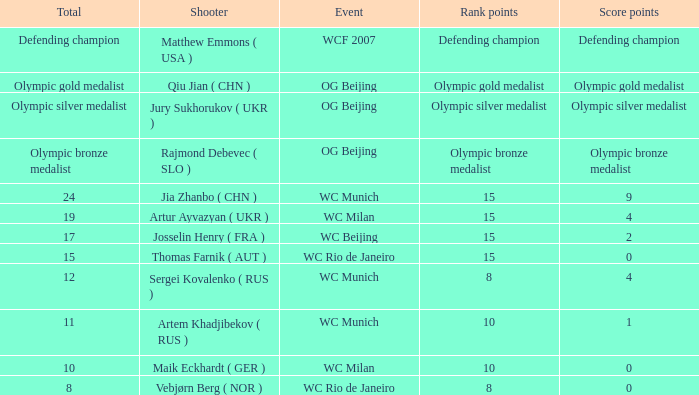With a total of 11, and 10 rank points, what are the score points? 1.0. Could you parse the entire table? {'header': ['Total', 'Shooter', 'Event', 'Rank points', 'Score points'], 'rows': [['Defending champion', 'Matthew Emmons ( USA )', 'WCF 2007', 'Defending champion', 'Defending champion'], ['Olympic gold medalist', 'Qiu Jian ( CHN )', 'OG Beijing', 'Olympic gold medalist', 'Olympic gold medalist'], ['Olympic silver medalist', 'Jury Sukhorukov ( UKR )', 'OG Beijing', 'Olympic silver medalist', 'Olympic silver medalist'], ['Olympic bronze medalist', 'Rajmond Debevec ( SLO )', 'OG Beijing', 'Olympic bronze medalist', 'Olympic bronze medalist'], ['24', 'Jia Zhanbo ( CHN )', 'WC Munich', '15', '9'], ['19', 'Artur Ayvazyan ( UKR )', 'WC Milan', '15', '4'], ['17', 'Josselin Henry ( FRA )', 'WC Beijing', '15', '2'], ['15', 'Thomas Farnik ( AUT )', 'WC Rio de Janeiro', '15', '0'], ['12', 'Sergei Kovalenko ( RUS )', 'WC Munich', '8', '4'], ['11', 'Artem Khadjibekov ( RUS )', 'WC Munich', '10', '1'], ['10', 'Maik Eckhardt ( GER )', 'WC Milan', '10', '0'], ['8', 'Vebjørn Berg ( NOR )', 'WC Rio de Janeiro', '8', '0']]} 